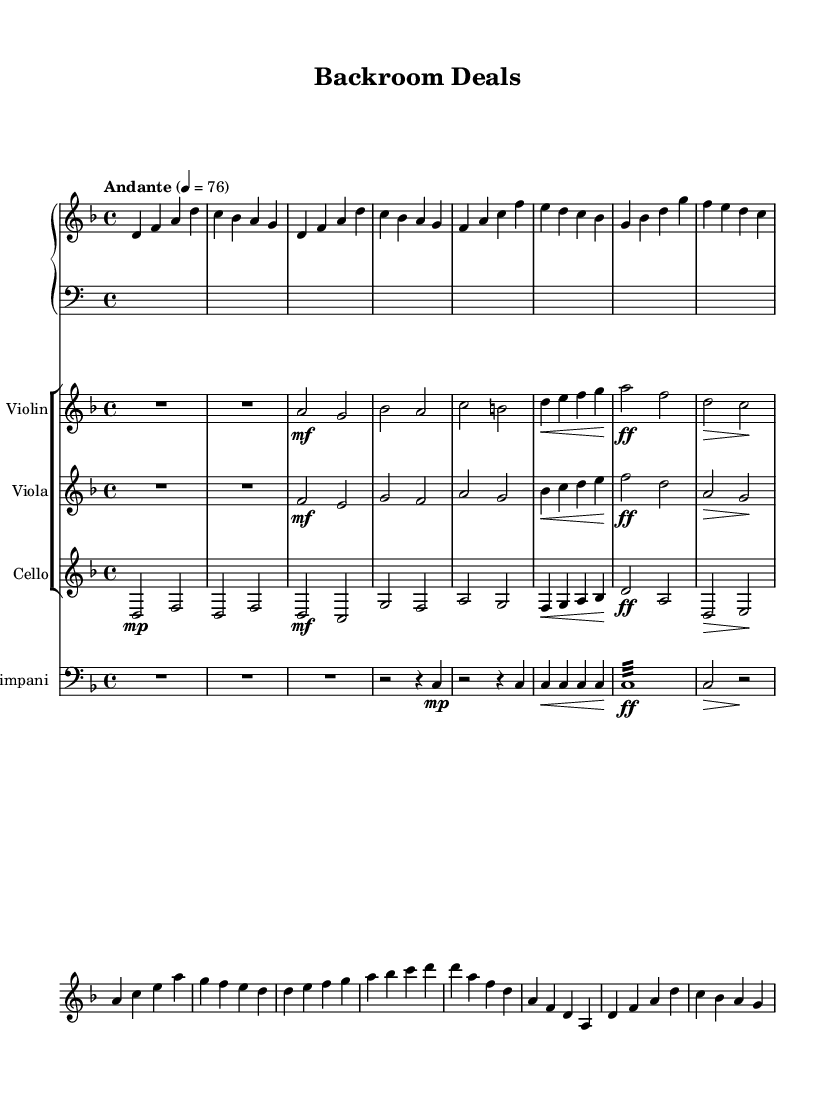What is the key signature of this music? The key signature is indicated at the beginning of the staff, displaying one flat (B flat) alongside D. This means the key is D minor, as D is the tonic note.
Answer: D minor What is the time signature of this music? The time signature appears at the beginning of the score and is written as a fraction, with a 4 on top and a 4 on the bottom, indicating that there are four beats in a measure, and the quarter note gets one beat.
Answer: 4/4 What is the tempo marking of this music? The tempo marking is usually found near the beginning. Here, it states "Andante" followed by a metronome marking of 76, which indicates a moderate walking pace.
Answer: Andante, 76 Which instrument has the first measure of rest? Looking at the first few measures, the notation provides a whole measure rest indicated by a "R" for the violin and viola parts, while the other instruments play.
Answer: Violin and Viola What dynamic marking does the cello have in measure 5? In measure 5 of the cello part, there is a dynamic marking "ff" which stands for fortissimo, indicating the musician should play very loudly.
Answer: fortissimo How many measures does the piano part have before the first rest? When counting through the measures in the piano part, there are 8 measures before encountering a rest, confirming that the piano part continues uninterrupted until then.
Answer: 8 measures What dynamic contrast does the viola exhibit between measure 4 and measure 5? The viola shows a dynamic contrast from a crescendo (from piano to fortissimo) in measure 4 to a louder dynamic in measure 5, which indicates an increase in intensity and energy in the music.
Answer: crescendo to fortissimo 